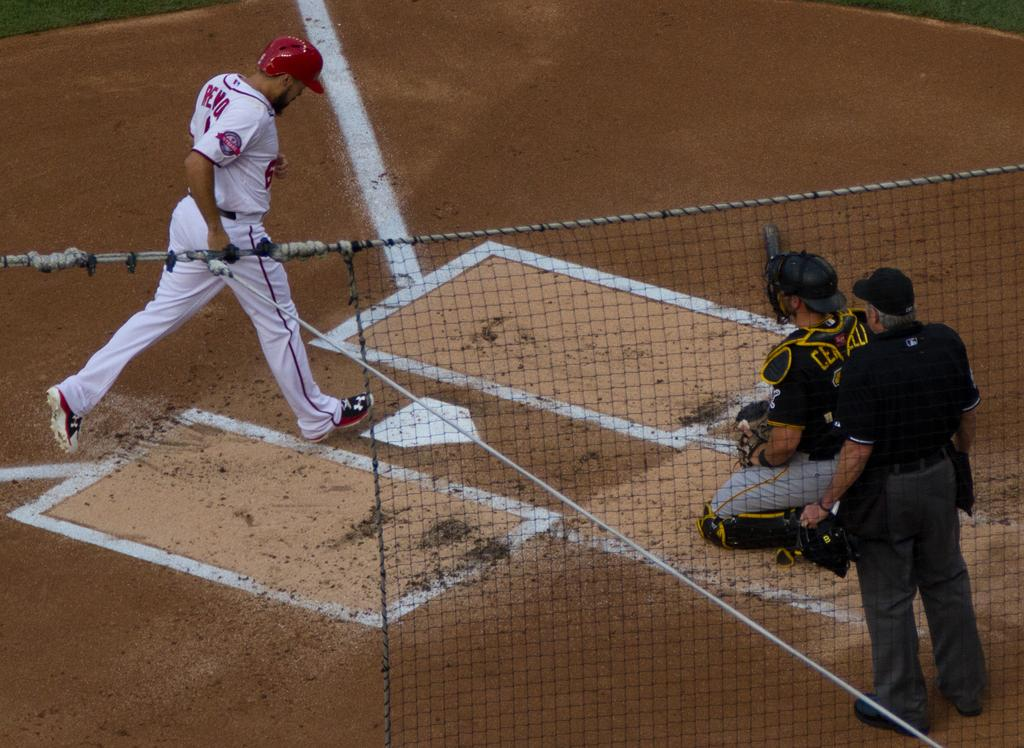What is the man on the left side of the image doing? The man is running on the left side of the image. What type of structure is depicted in the image? There is an empire in the image. What role does the person in the image have? There is a wicketkeeper in the image. What is present in the foreground of the image? There is a net in the foreground of the image. What shape of the fork used by the wicketkeeper in the image? There is no fork present in the image, as it is related to a different context. 